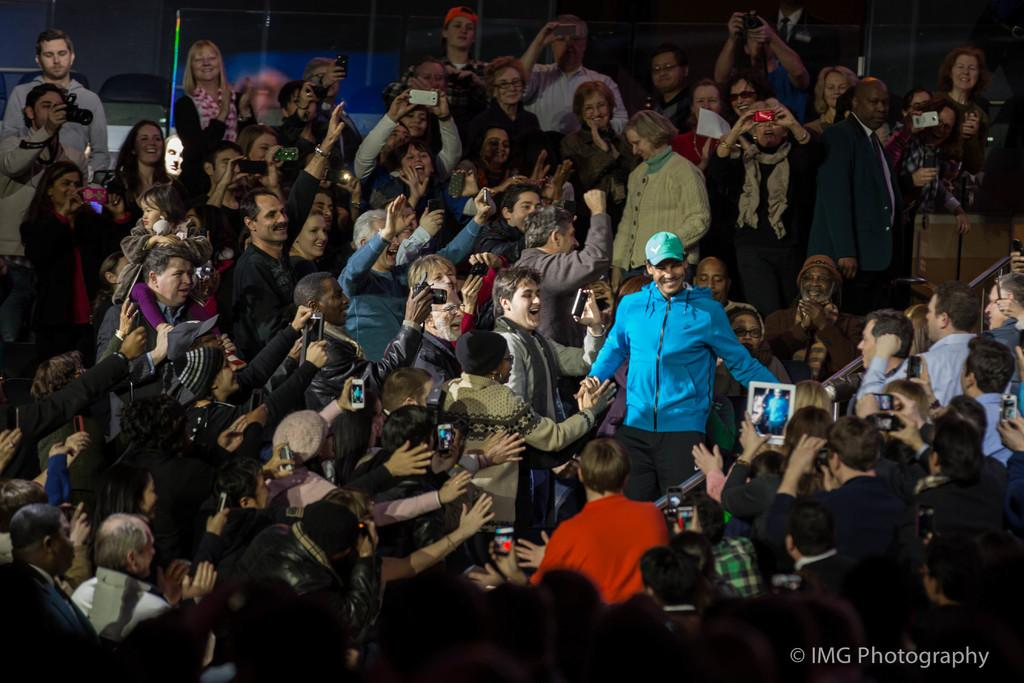What are the people in the image doing? The people in the image are standing and holding cameras and mobiles. What objects can be seen in the image besides the people? There are iron rods and chairs in the image. Is there any indication of the image being modified or protected? Yes, the image has a watermark. What type of offer is being made by the people in the image? There is no indication of an offer being made in the image; the people are simply standing and holding cameras and mobiles. Can you describe the breath of the people in the image? There is no way to determine the breath of the people in the image from the provided facts. 